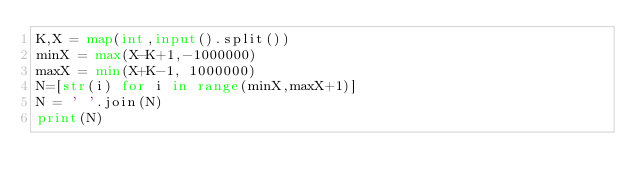Convert code to text. <code><loc_0><loc_0><loc_500><loc_500><_Python_>K,X = map(int,input().split())
minX = max(X-K+1,-1000000)
maxX = min(X+K-1, 1000000)
N=[str(i) for i in range(minX,maxX+1)]
N = ' '.join(N)
print(N)</code> 